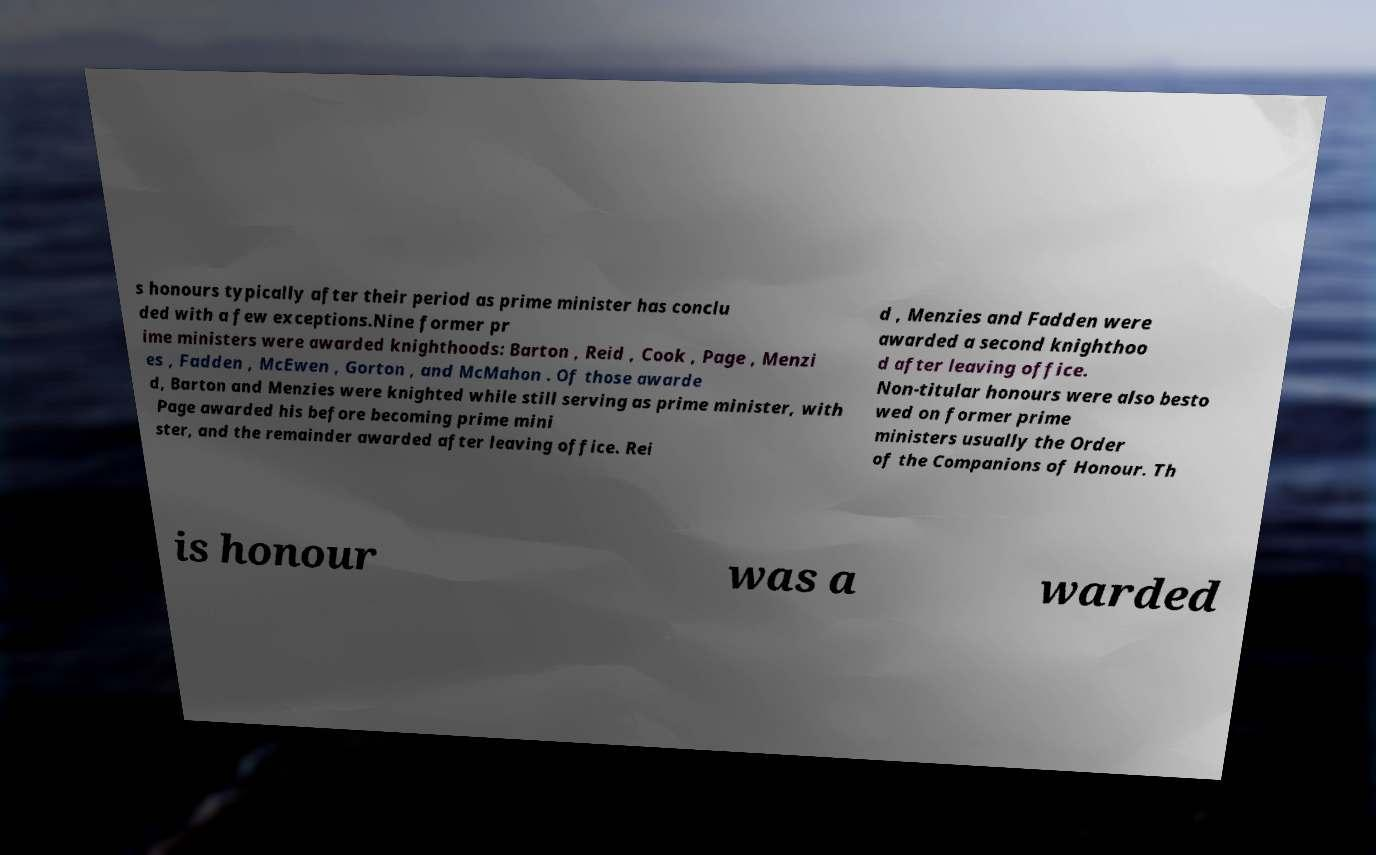There's text embedded in this image that I need extracted. Can you transcribe it verbatim? s honours typically after their period as prime minister has conclu ded with a few exceptions.Nine former pr ime ministers were awarded knighthoods: Barton , Reid , Cook , Page , Menzi es , Fadden , McEwen , Gorton , and McMahon . Of those awarde d, Barton and Menzies were knighted while still serving as prime minister, with Page awarded his before becoming prime mini ster, and the remainder awarded after leaving office. Rei d , Menzies and Fadden were awarded a second knighthoo d after leaving office. Non-titular honours were also besto wed on former prime ministers usually the Order of the Companions of Honour. Th is honour was a warded 